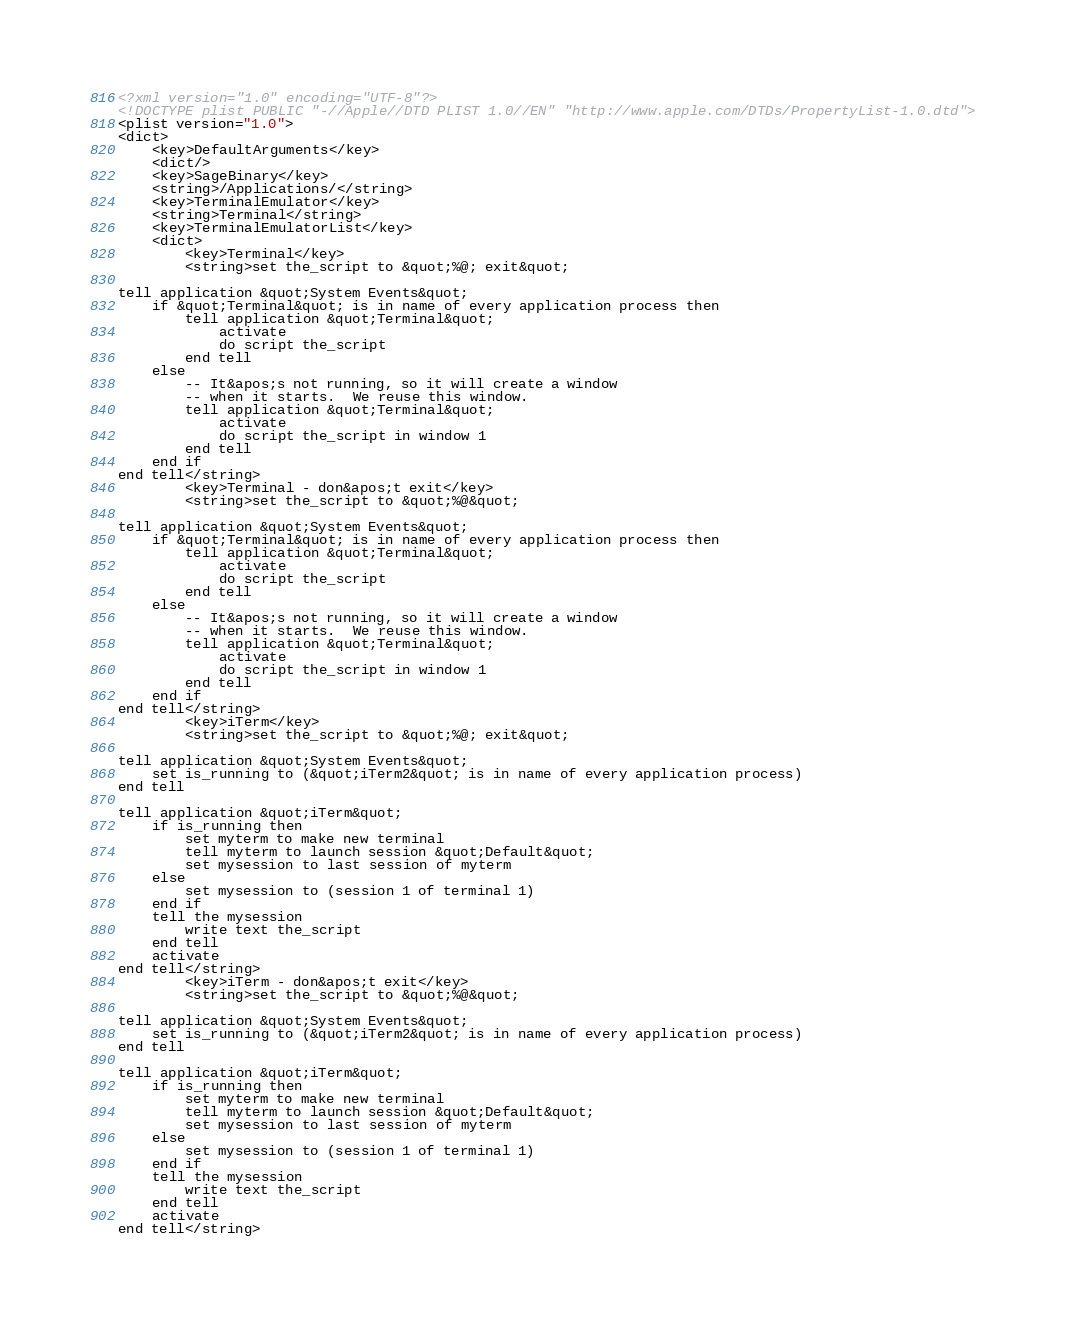Convert code to text. <code><loc_0><loc_0><loc_500><loc_500><_XML_><?xml version="1.0" encoding="UTF-8"?>
<!DOCTYPE plist PUBLIC "-//Apple//DTD PLIST 1.0//EN" "http://www.apple.com/DTDs/PropertyList-1.0.dtd">
<plist version="1.0">
<dict>
	<key>DefaultArguments</key>
	<dict/>
	<key>SageBinary</key>
	<string>/Applications/</string>
	<key>TerminalEmulator</key>
	<string>Terminal</string>
	<key>TerminalEmulatorList</key>
	<dict>
		<key>Terminal</key>
		<string>set the_script to &quot;%@; exit&quot;

tell application &quot;System Events&quot;
	if &quot;Terminal&quot; is in name of every application process then
		tell application &quot;Terminal&quot;
			activate
			do script the_script
		end tell
	else
		-- It&apos;s not running, so it will create a window
		-- when it starts.  We reuse this window.
		tell application &quot;Terminal&quot;
			activate
			do script the_script in window 1
		end tell
	end if
end tell</string>
		<key>Terminal - don&apos;t exit</key>
		<string>set the_script to &quot;%@&quot;

tell application &quot;System Events&quot;
	if &quot;Terminal&quot; is in name of every application process then
		tell application &quot;Terminal&quot;
			activate
			do script the_script
		end tell
	else
		-- It&apos;s not running, so it will create a window
		-- when it starts.  We reuse this window.
		tell application &quot;Terminal&quot;
			activate
			do script the_script in window 1
		end tell
	end if
end tell</string>
		<key>iTerm</key>
		<string>set the_script to &quot;%@; exit&quot;

tell application &quot;System Events&quot;
	set is_running to (&quot;iTerm2&quot; is in name of every application process)
end tell

tell application &quot;iTerm&quot;
	if is_running then
		set myterm to make new terminal
		tell myterm to launch session &quot;Default&quot;
		set mysession to last session of myterm
	else
		set mysession to (session 1 of terminal 1)
	end if
	tell the mysession
		write text the_script
	end tell
	activate
end tell</string>
		<key>iTerm - don&apos;t exit</key>
		<string>set the_script to &quot;%@&quot;

tell application &quot;System Events&quot;
	set is_running to (&quot;iTerm2&quot; is in name of every application process)
end tell

tell application &quot;iTerm&quot;
	if is_running then
		set myterm to make new terminal
		tell myterm to launch session &quot;Default&quot;
		set mysession to last session of myterm
	else
		set mysession to (session 1 of terminal 1)
	end if
	tell the mysession
		write text the_script
	end tell
	activate
end tell</string></code> 